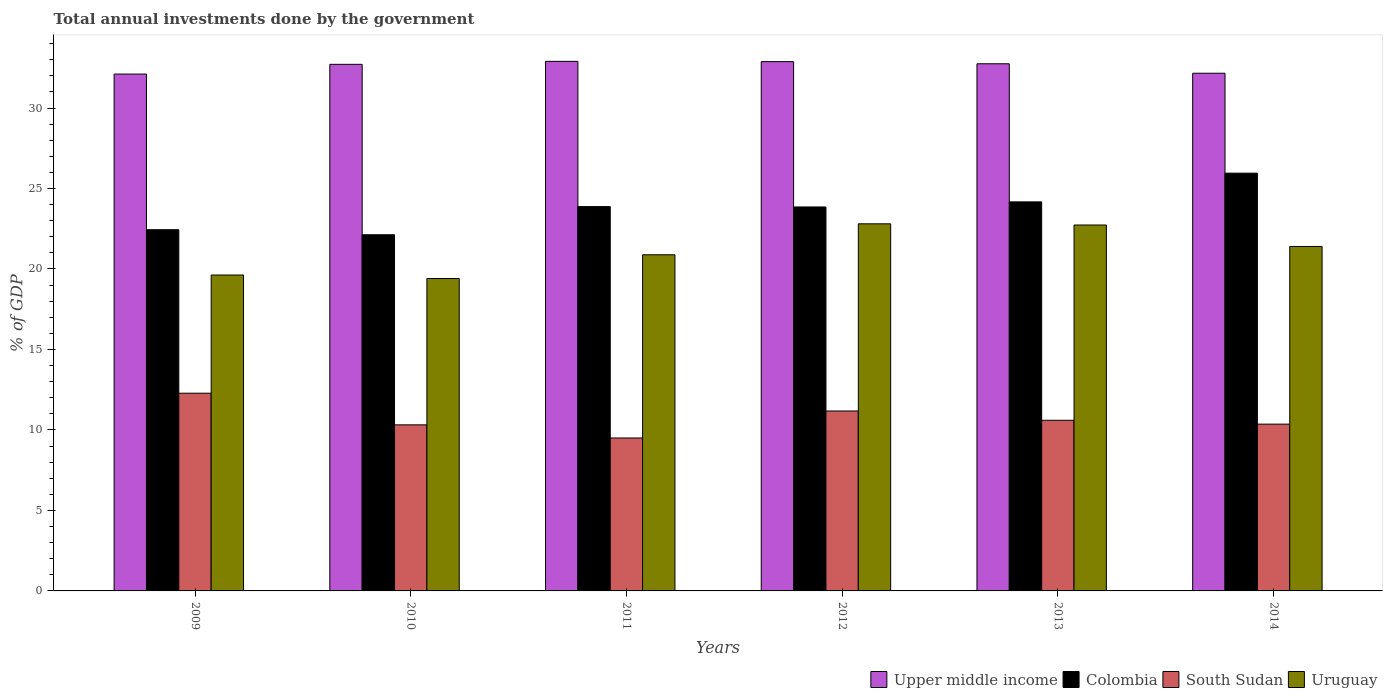How many different coloured bars are there?
Give a very brief answer. 4. How many groups of bars are there?
Provide a short and direct response. 6. How many bars are there on the 5th tick from the right?
Keep it short and to the point. 4. In how many cases, is the number of bars for a given year not equal to the number of legend labels?
Keep it short and to the point. 0. What is the total annual investments done by the government in Upper middle income in 2011?
Give a very brief answer. 32.9. Across all years, what is the maximum total annual investments done by the government in Upper middle income?
Your answer should be very brief. 32.9. Across all years, what is the minimum total annual investments done by the government in Upper middle income?
Offer a terse response. 32.11. In which year was the total annual investments done by the government in Colombia maximum?
Ensure brevity in your answer.  2014. What is the total total annual investments done by the government in Colombia in the graph?
Provide a succinct answer. 142.42. What is the difference between the total annual investments done by the government in Colombia in 2009 and that in 2010?
Ensure brevity in your answer.  0.31. What is the difference between the total annual investments done by the government in South Sudan in 2009 and the total annual investments done by the government in Upper middle income in 2013?
Offer a terse response. -20.47. What is the average total annual investments done by the government in Colombia per year?
Make the answer very short. 23.74. In the year 2012, what is the difference between the total annual investments done by the government in South Sudan and total annual investments done by the government in Uruguay?
Offer a very short reply. -11.63. In how many years, is the total annual investments done by the government in Colombia greater than 24 %?
Provide a succinct answer. 2. What is the ratio of the total annual investments done by the government in South Sudan in 2010 to that in 2011?
Keep it short and to the point. 1.09. Is the total annual investments done by the government in Upper middle income in 2009 less than that in 2012?
Your answer should be very brief. Yes. Is the difference between the total annual investments done by the government in South Sudan in 2010 and 2014 greater than the difference between the total annual investments done by the government in Uruguay in 2010 and 2014?
Give a very brief answer. Yes. What is the difference between the highest and the second highest total annual investments done by the government in Upper middle income?
Your response must be concise. 0.02. What is the difference between the highest and the lowest total annual investments done by the government in Uruguay?
Make the answer very short. 3.4. In how many years, is the total annual investments done by the government in South Sudan greater than the average total annual investments done by the government in South Sudan taken over all years?
Your answer should be compact. 2. Is the sum of the total annual investments done by the government in South Sudan in 2012 and 2014 greater than the maximum total annual investments done by the government in Upper middle income across all years?
Provide a short and direct response. No. Is it the case that in every year, the sum of the total annual investments done by the government in Colombia and total annual investments done by the government in Upper middle income is greater than the sum of total annual investments done by the government in South Sudan and total annual investments done by the government in Uruguay?
Your response must be concise. Yes. What does the 4th bar from the left in 2014 represents?
Provide a succinct answer. Uruguay. What does the 1st bar from the right in 2009 represents?
Provide a succinct answer. Uruguay. What is the difference between two consecutive major ticks on the Y-axis?
Provide a short and direct response. 5. Are the values on the major ticks of Y-axis written in scientific E-notation?
Your answer should be compact. No. Does the graph contain any zero values?
Your answer should be compact. No. Does the graph contain grids?
Your response must be concise. No. How are the legend labels stacked?
Keep it short and to the point. Horizontal. What is the title of the graph?
Offer a very short reply. Total annual investments done by the government. Does "Cote d'Ivoire" appear as one of the legend labels in the graph?
Ensure brevity in your answer.  No. What is the label or title of the Y-axis?
Your answer should be compact. % of GDP. What is the % of GDP of Upper middle income in 2009?
Your response must be concise. 32.11. What is the % of GDP in Colombia in 2009?
Your answer should be compact. 22.44. What is the % of GDP in South Sudan in 2009?
Keep it short and to the point. 12.28. What is the % of GDP of Uruguay in 2009?
Provide a short and direct response. 19.62. What is the % of GDP in Upper middle income in 2010?
Your response must be concise. 32.71. What is the % of GDP of Colombia in 2010?
Your response must be concise. 22.13. What is the % of GDP in South Sudan in 2010?
Provide a short and direct response. 10.32. What is the % of GDP of Uruguay in 2010?
Ensure brevity in your answer.  19.41. What is the % of GDP of Upper middle income in 2011?
Keep it short and to the point. 32.9. What is the % of GDP in Colombia in 2011?
Make the answer very short. 23.88. What is the % of GDP in South Sudan in 2011?
Your response must be concise. 9.5. What is the % of GDP of Uruguay in 2011?
Your response must be concise. 20.88. What is the % of GDP of Upper middle income in 2012?
Keep it short and to the point. 32.88. What is the % of GDP in Colombia in 2012?
Ensure brevity in your answer.  23.85. What is the % of GDP in South Sudan in 2012?
Keep it short and to the point. 11.18. What is the % of GDP of Uruguay in 2012?
Make the answer very short. 22.81. What is the % of GDP in Upper middle income in 2013?
Offer a terse response. 32.75. What is the % of GDP in Colombia in 2013?
Ensure brevity in your answer.  24.17. What is the % of GDP in South Sudan in 2013?
Offer a very short reply. 10.6. What is the % of GDP of Uruguay in 2013?
Keep it short and to the point. 22.73. What is the % of GDP of Upper middle income in 2014?
Keep it short and to the point. 32.16. What is the % of GDP of Colombia in 2014?
Your answer should be very brief. 25.95. What is the % of GDP in South Sudan in 2014?
Your answer should be compact. 10.36. What is the % of GDP of Uruguay in 2014?
Give a very brief answer. 21.4. Across all years, what is the maximum % of GDP of Upper middle income?
Offer a terse response. 32.9. Across all years, what is the maximum % of GDP of Colombia?
Offer a terse response. 25.95. Across all years, what is the maximum % of GDP in South Sudan?
Keep it short and to the point. 12.28. Across all years, what is the maximum % of GDP of Uruguay?
Your response must be concise. 22.81. Across all years, what is the minimum % of GDP in Upper middle income?
Your response must be concise. 32.11. Across all years, what is the minimum % of GDP of Colombia?
Your answer should be compact. 22.13. Across all years, what is the minimum % of GDP of South Sudan?
Keep it short and to the point. 9.5. Across all years, what is the minimum % of GDP of Uruguay?
Offer a very short reply. 19.41. What is the total % of GDP in Upper middle income in the graph?
Your answer should be very brief. 195.51. What is the total % of GDP in Colombia in the graph?
Your answer should be very brief. 142.42. What is the total % of GDP of South Sudan in the graph?
Offer a very short reply. 64.24. What is the total % of GDP of Uruguay in the graph?
Ensure brevity in your answer.  126.85. What is the difference between the % of GDP of Upper middle income in 2009 and that in 2010?
Your response must be concise. -0.6. What is the difference between the % of GDP in Colombia in 2009 and that in 2010?
Provide a short and direct response. 0.31. What is the difference between the % of GDP of South Sudan in 2009 and that in 2010?
Keep it short and to the point. 1.97. What is the difference between the % of GDP in Uruguay in 2009 and that in 2010?
Your response must be concise. 0.22. What is the difference between the % of GDP of Upper middle income in 2009 and that in 2011?
Provide a succinct answer. -0.79. What is the difference between the % of GDP in Colombia in 2009 and that in 2011?
Give a very brief answer. -1.44. What is the difference between the % of GDP of South Sudan in 2009 and that in 2011?
Your response must be concise. 2.78. What is the difference between the % of GDP of Uruguay in 2009 and that in 2011?
Your answer should be very brief. -1.26. What is the difference between the % of GDP of Upper middle income in 2009 and that in 2012?
Offer a terse response. -0.77. What is the difference between the % of GDP in Colombia in 2009 and that in 2012?
Your response must be concise. -1.41. What is the difference between the % of GDP in South Sudan in 2009 and that in 2012?
Provide a short and direct response. 1.1. What is the difference between the % of GDP in Uruguay in 2009 and that in 2012?
Provide a succinct answer. -3.18. What is the difference between the % of GDP of Upper middle income in 2009 and that in 2013?
Keep it short and to the point. -0.64. What is the difference between the % of GDP in Colombia in 2009 and that in 2013?
Give a very brief answer. -1.73. What is the difference between the % of GDP in South Sudan in 2009 and that in 2013?
Make the answer very short. 1.68. What is the difference between the % of GDP of Uruguay in 2009 and that in 2013?
Give a very brief answer. -3.11. What is the difference between the % of GDP of Upper middle income in 2009 and that in 2014?
Your answer should be very brief. -0.05. What is the difference between the % of GDP in Colombia in 2009 and that in 2014?
Provide a succinct answer. -3.51. What is the difference between the % of GDP of South Sudan in 2009 and that in 2014?
Provide a short and direct response. 1.92. What is the difference between the % of GDP in Uruguay in 2009 and that in 2014?
Your answer should be compact. -1.77. What is the difference between the % of GDP of Upper middle income in 2010 and that in 2011?
Offer a terse response. -0.19. What is the difference between the % of GDP of Colombia in 2010 and that in 2011?
Your response must be concise. -1.75. What is the difference between the % of GDP of South Sudan in 2010 and that in 2011?
Keep it short and to the point. 0.82. What is the difference between the % of GDP in Uruguay in 2010 and that in 2011?
Give a very brief answer. -1.47. What is the difference between the % of GDP of Upper middle income in 2010 and that in 2012?
Your response must be concise. -0.17. What is the difference between the % of GDP of Colombia in 2010 and that in 2012?
Provide a short and direct response. -1.73. What is the difference between the % of GDP of South Sudan in 2010 and that in 2012?
Give a very brief answer. -0.86. What is the difference between the % of GDP of Uruguay in 2010 and that in 2012?
Offer a terse response. -3.4. What is the difference between the % of GDP of Upper middle income in 2010 and that in 2013?
Your answer should be compact. -0.04. What is the difference between the % of GDP of Colombia in 2010 and that in 2013?
Your answer should be very brief. -2.04. What is the difference between the % of GDP in South Sudan in 2010 and that in 2013?
Ensure brevity in your answer.  -0.28. What is the difference between the % of GDP of Uruguay in 2010 and that in 2013?
Offer a terse response. -3.32. What is the difference between the % of GDP of Upper middle income in 2010 and that in 2014?
Make the answer very short. 0.55. What is the difference between the % of GDP in Colombia in 2010 and that in 2014?
Your answer should be very brief. -3.83. What is the difference between the % of GDP in South Sudan in 2010 and that in 2014?
Provide a succinct answer. -0.04. What is the difference between the % of GDP of Uruguay in 2010 and that in 2014?
Provide a short and direct response. -1.99. What is the difference between the % of GDP in Upper middle income in 2011 and that in 2012?
Make the answer very short. 0.02. What is the difference between the % of GDP in Colombia in 2011 and that in 2012?
Provide a succinct answer. 0.02. What is the difference between the % of GDP in South Sudan in 2011 and that in 2012?
Your answer should be compact. -1.68. What is the difference between the % of GDP in Uruguay in 2011 and that in 2012?
Make the answer very short. -1.92. What is the difference between the % of GDP in Colombia in 2011 and that in 2013?
Ensure brevity in your answer.  -0.29. What is the difference between the % of GDP in South Sudan in 2011 and that in 2013?
Your answer should be compact. -1.1. What is the difference between the % of GDP of Uruguay in 2011 and that in 2013?
Keep it short and to the point. -1.85. What is the difference between the % of GDP of Upper middle income in 2011 and that in 2014?
Offer a very short reply. 0.74. What is the difference between the % of GDP of Colombia in 2011 and that in 2014?
Give a very brief answer. -2.08. What is the difference between the % of GDP of South Sudan in 2011 and that in 2014?
Keep it short and to the point. -0.86. What is the difference between the % of GDP in Uruguay in 2011 and that in 2014?
Give a very brief answer. -0.52. What is the difference between the % of GDP in Upper middle income in 2012 and that in 2013?
Offer a terse response. 0.13. What is the difference between the % of GDP in Colombia in 2012 and that in 2013?
Offer a terse response. -0.32. What is the difference between the % of GDP in South Sudan in 2012 and that in 2013?
Make the answer very short. 0.58. What is the difference between the % of GDP in Uruguay in 2012 and that in 2013?
Provide a succinct answer. 0.07. What is the difference between the % of GDP of Upper middle income in 2012 and that in 2014?
Your response must be concise. 0.72. What is the difference between the % of GDP in Colombia in 2012 and that in 2014?
Give a very brief answer. -2.1. What is the difference between the % of GDP in South Sudan in 2012 and that in 2014?
Your answer should be very brief. 0.82. What is the difference between the % of GDP of Uruguay in 2012 and that in 2014?
Make the answer very short. 1.41. What is the difference between the % of GDP of Upper middle income in 2013 and that in 2014?
Your answer should be very brief. 0.59. What is the difference between the % of GDP in Colombia in 2013 and that in 2014?
Ensure brevity in your answer.  -1.78. What is the difference between the % of GDP in South Sudan in 2013 and that in 2014?
Provide a succinct answer. 0.24. What is the difference between the % of GDP of Uruguay in 2013 and that in 2014?
Give a very brief answer. 1.33. What is the difference between the % of GDP in Upper middle income in 2009 and the % of GDP in Colombia in 2010?
Offer a terse response. 9.98. What is the difference between the % of GDP of Upper middle income in 2009 and the % of GDP of South Sudan in 2010?
Your response must be concise. 21.79. What is the difference between the % of GDP in Upper middle income in 2009 and the % of GDP in Uruguay in 2010?
Provide a succinct answer. 12.7. What is the difference between the % of GDP of Colombia in 2009 and the % of GDP of South Sudan in 2010?
Ensure brevity in your answer.  12.12. What is the difference between the % of GDP of Colombia in 2009 and the % of GDP of Uruguay in 2010?
Your answer should be very brief. 3.03. What is the difference between the % of GDP in South Sudan in 2009 and the % of GDP in Uruguay in 2010?
Your answer should be very brief. -7.13. What is the difference between the % of GDP of Upper middle income in 2009 and the % of GDP of Colombia in 2011?
Keep it short and to the point. 8.23. What is the difference between the % of GDP in Upper middle income in 2009 and the % of GDP in South Sudan in 2011?
Your answer should be compact. 22.61. What is the difference between the % of GDP in Upper middle income in 2009 and the % of GDP in Uruguay in 2011?
Your answer should be compact. 11.23. What is the difference between the % of GDP in Colombia in 2009 and the % of GDP in South Sudan in 2011?
Make the answer very short. 12.94. What is the difference between the % of GDP in Colombia in 2009 and the % of GDP in Uruguay in 2011?
Provide a succinct answer. 1.56. What is the difference between the % of GDP in Upper middle income in 2009 and the % of GDP in Colombia in 2012?
Provide a succinct answer. 8.26. What is the difference between the % of GDP in Upper middle income in 2009 and the % of GDP in South Sudan in 2012?
Offer a very short reply. 20.93. What is the difference between the % of GDP in Upper middle income in 2009 and the % of GDP in Uruguay in 2012?
Give a very brief answer. 9.3. What is the difference between the % of GDP in Colombia in 2009 and the % of GDP in South Sudan in 2012?
Your response must be concise. 11.26. What is the difference between the % of GDP of Colombia in 2009 and the % of GDP of Uruguay in 2012?
Give a very brief answer. -0.37. What is the difference between the % of GDP in South Sudan in 2009 and the % of GDP in Uruguay in 2012?
Offer a terse response. -10.52. What is the difference between the % of GDP of Upper middle income in 2009 and the % of GDP of Colombia in 2013?
Your answer should be compact. 7.94. What is the difference between the % of GDP in Upper middle income in 2009 and the % of GDP in South Sudan in 2013?
Keep it short and to the point. 21.51. What is the difference between the % of GDP in Upper middle income in 2009 and the % of GDP in Uruguay in 2013?
Give a very brief answer. 9.38. What is the difference between the % of GDP in Colombia in 2009 and the % of GDP in South Sudan in 2013?
Offer a terse response. 11.84. What is the difference between the % of GDP of Colombia in 2009 and the % of GDP of Uruguay in 2013?
Provide a short and direct response. -0.29. What is the difference between the % of GDP in South Sudan in 2009 and the % of GDP in Uruguay in 2013?
Provide a short and direct response. -10.45. What is the difference between the % of GDP in Upper middle income in 2009 and the % of GDP in Colombia in 2014?
Your answer should be very brief. 6.16. What is the difference between the % of GDP of Upper middle income in 2009 and the % of GDP of South Sudan in 2014?
Your answer should be very brief. 21.75. What is the difference between the % of GDP of Upper middle income in 2009 and the % of GDP of Uruguay in 2014?
Give a very brief answer. 10.71. What is the difference between the % of GDP of Colombia in 2009 and the % of GDP of South Sudan in 2014?
Ensure brevity in your answer.  12.08. What is the difference between the % of GDP of Colombia in 2009 and the % of GDP of Uruguay in 2014?
Offer a very short reply. 1.04. What is the difference between the % of GDP of South Sudan in 2009 and the % of GDP of Uruguay in 2014?
Give a very brief answer. -9.12. What is the difference between the % of GDP in Upper middle income in 2010 and the % of GDP in Colombia in 2011?
Provide a succinct answer. 8.84. What is the difference between the % of GDP of Upper middle income in 2010 and the % of GDP of South Sudan in 2011?
Offer a very short reply. 23.21. What is the difference between the % of GDP in Upper middle income in 2010 and the % of GDP in Uruguay in 2011?
Give a very brief answer. 11.83. What is the difference between the % of GDP in Colombia in 2010 and the % of GDP in South Sudan in 2011?
Your response must be concise. 12.62. What is the difference between the % of GDP of Colombia in 2010 and the % of GDP of Uruguay in 2011?
Offer a terse response. 1.24. What is the difference between the % of GDP in South Sudan in 2010 and the % of GDP in Uruguay in 2011?
Give a very brief answer. -10.57. What is the difference between the % of GDP in Upper middle income in 2010 and the % of GDP in Colombia in 2012?
Make the answer very short. 8.86. What is the difference between the % of GDP in Upper middle income in 2010 and the % of GDP in South Sudan in 2012?
Make the answer very short. 21.54. What is the difference between the % of GDP of Upper middle income in 2010 and the % of GDP of Uruguay in 2012?
Your answer should be very brief. 9.91. What is the difference between the % of GDP in Colombia in 2010 and the % of GDP in South Sudan in 2012?
Ensure brevity in your answer.  10.95. What is the difference between the % of GDP of Colombia in 2010 and the % of GDP of Uruguay in 2012?
Give a very brief answer. -0.68. What is the difference between the % of GDP in South Sudan in 2010 and the % of GDP in Uruguay in 2012?
Your answer should be compact. -12.49. What is the difference between the % of GDP in Upper middle income in 2010 and the % of GDP in Colombia in 2013?
Give a very brief answer. 8.54. What is the difference between the % of GDP of Upper middle income in 2010 and the % of GDP of South Sudan in 2013?
Your answer should be compact. 22.11. What is the difference between the % of GDP of Upper middle income in 2010 and the % of GDP of Uruguay in 2013?
Provide a short and direct response. 9.98. What is the difference between the % of GDP of Colombia in 2010 and the % of GDP of South Sudan in 2013?
Your answer should be very brief. 11.53. What is the difference between the % of GDP of Colombia in 2010 and the % of GDP of Uruguay in 2013?
Offer a very short reply. -0.61. What is the difference between the % of GDP in South Sudan in 2010 and the % of GDP in Uruguay in 2013?
Ensure brevity in your answer.  -12.41. What is the difference between the % of GDP of Upper middle income in 2010 and the % of GDP of Colombia in 2014?
Provide a succinct answer. 6.76. What is the difference between the % of GDP of Upper middle income in 2010 and the % of GDP of South Sudan in 2014?
Your answer should be compact. 22.35. What is the difference between the % of GDP of Upper middle income in 2010 and the % of GDP of Uruguay in 2014?
Offer a terse response. 11.31. What is the difference between the % of GDP of Colombia in 2010 and the % of GDP of South Sudan in 2014?
Make the answer very short. 11.76. What is the difference between the % of GDP of Colombia in 2010 and the % of GDP of Uruguay in 2014?
Offer a very short reply. 0.73. What is the difference between the % of GDP of South Sudan in 2010 and the % of GDP of Uruguay in 2014?
Give a very brief answer. -11.08. What is the difference between the % of GDP of Upper middle income in 2011 and the % of GDP of Colombia in 2012?
Your answer should be very brief. 9.05. What is the difference between the % of GDP of Upper middle income in 2011 and the % of GDP of South Sudan in 2012?
Give a very brief answer. 21.72. What is the difference between the % of GDP in Upper middle income in 2011 and the % of GDP in Uruguay in 2012?
Provide a short and direct response. 10.09. What is the difference between the % of GDP of Colombia in 2011 and the % of GDP of South Sudan in 2012?
Keep it short and to the point. 12.7. What is the difference between the % of GDP of Colombia in 2011 and the % of GDP of Uruguay in 2012?
Offer a very short reply. 1.07. What is the difference between the % of GDP in South Sudan in 2011 and the % of GDP in Uruguay in 2012?
Your response must be concise. -13.3. What is the difference between the % of GDP in Upper middle income in 2011 and the % of GDP in Colombia in 2013?
Ensure brevity in your answer.  8.73. What is the difference between the % of GDP of Upper middle income in 2011 and the % of GDP of South Sudan in 2013?
Provide a succinct answer. 22.3. What is the difference between the % of GDP of Upper middle income in 2011 and the % of GDP of Uruguay in 2013?
Provide a succinct answer. 10.17. What is the difference between the % of GDP of Colombia in 2011 and the % of GDP of South Sudan in 2013?
Offer a terse response. 13.28. What is the difference between the % of GDP in Colombia in 2011 and the % of GDP in Uruguay in 2013?
Ensure brevity in your answer.  1.14. What is the difference between the % of GDP in South Sudan in 2011 and the % of GDP in Uruguay in 2013?
Provide a short and direct response. -13.23. What is the difference between the % of GDP of Upper middle income in 2011 and the % of GDP of Colombia in 2014?
Provide a short and direct response. 6.95. What is the difference between the % of GDP in Upper middle income in 2011 and the % of GDP in South Sudan in 2014?
Make the answer very short. 22.54. What is the difference between the % of GDP of Colombia in 2011 and the % of GDP of South Sudan in 2014?
Keep it short and to the point. 13.51. What is the difference between the % of GDP of Colombia in 2011 and the % of GDP of Uruguay in 2014?
Provide a short and direct response. 2.48. What is the difference between the % of GDP of South Sudan in 2011 and the % of GDP of Uruguay in 2014?
Provide a short and direct response. -11.9. What is the difference between the % of GDP in Upper middle income in 2012 and the % of GDP in Colombia in 2013?
Your response must be concise. 8.71. What is the difference between the % of GDP in Upper middle income in 2012 and the % of GDP in South Sudan in 2013?
Provide a succinct answer. 22.28. What is the difference between the % of GDP of Upper middle income in 2012 and the % of GDP of Uruguay in 2013?
Give a very brief answer. 10.15. What is the difference between the % of GDP in Colombia in 2012 and the % of GDP in South Sudan in 2013?
Provide a short and direct response. 13.25. What is the difference between the % of GDP in Colombia in 2012 and the % of GDP in Uruguay in 2013?
Your answer should be compact. 1.12. What is the difference between the % of GDP of South Sudan in 2012 and the % of GDP of Uruguay in 2013?
Offer a very short reply. -11.55. What is the difference between the % of GDP in Upper middle income in 2012 and the % of GDP in Colombia in 2014?
Offer a terse response. 6.93. What is the difference between the % of GDP in Upper middle income in 2012 and the % of GDP in South Sudan in 2014?
Your answer should be very brief. 22.52. What is the difference between the % of GDP in Upper middle income in 2012 and the % of GDP in Uruguay in 2014?
Your response must be concise. 11.48. What is the difference between the % of GDP in Colombia in 2012 and the % of GDP in South Sudan in 2014?
Provide a short and direct response. 13.49. What is the difference between the % of GDP of Colombia in 2012 and the % of GDP of Uruguay in 2014?
Provide a succinct answer. 2.45. What is the difference between the % of GDP of South Sudan in 2012 and the % of GDP of Uruguay in 2014?
Provide a short and direct response. -10.22. What is the difference between the % of GDP of Upper middle income in 2013 and the % of GDP of Colombia in 2014?
Your answer should be very brief. 6.8. What is the difference between the % of GDP of Upper middle income in 2013 and the % of GDP of South Sudan in 2014?
Your answer should be very brief. 22.39. What is the difference between the % of GDP of Upper middle income in 2013 and the % of GDP of Uruguay in 2014?
Give a very brief answer. 11.35. What is the difference between the % of GDP in Colombia in 2013 and the % of GDP in South Sudan in 2014?
Ensure brevity in your answer.  13.81. What is the difference between the % of GDP of Colombia in 2013 and the % of GDP of Uruguay in 2014?
Offer a terse response. 2.77. What is the difference between the % of GDP of South Sudan in 2013 and the % of GDP of Uruguay in 2014?
Provide a succinct answer. -10.8. What is the average % of GDP in Upper middle income per year?
Offer a terse response. 32.58. What is the average % of GDP of Colombia per year?
Make the answer very short. 23.74. What is the average % of GDP in South Sudan per year?
Your answer should be very brief. 10.71. What is the average % of GDP of Uruguay per year?
Give a very brief answer. 21.14. In the year 2009, what is the difference between the % of GDP of Upper middle income and % of GDP of Colombia?
Provide a short and direct response. 9.67. In the year 2009, what is the difference between the % of GDP of Upper middle income and % of GDP of South Sudan?
Offer a very short reply. 19.83. In the year 2009, what is the difference between the % of GDP of Upper middle income and % of GDP of Uruguay?
Your answer should be very brief. 12.48. In the year 2009, what is the difference between the % of GDP of Colombia and % of GDP of South Sudan?
Your answer should be compact. 10.16. In the year 2009, what is the difference between the % of GDP of Colombia and % of GDP of Uruguay?
Offer a terse response. 2.82. In the year 2009, what is the difference between the % of GDP in South Sudan and % of GDP in Uruguay?
Your response must be concise. -7.34. In the year 2010, what is the difference between the % of GDP in Upper middle income and % of GDP in Colombia?
Provide a succinct answer. 10.59. In the year 2010, what is the difference between the % of GDP of Upper middle income and % of GDP of South Sudan?
Your answer should be compact. 22.4. In the year 2010, what is the difference between the % of GDP in Upper middle income and % of GDP in Uruguay?
Give a very brief answer. 13.31. In the year 2010, what is the difference between the % of GDP in Colombia and % of GDP in South Sudan?
Offer a terse response. 11.81. In the year 2010, what is the difference between the % of GDP of Colombia and % of GDP of Uruguay?
Offer a very short reply. 2.72. In the year 2010, what is the difference between the % of GDP of South Sudan and % of GDP of Uruguay?
Offer a terse response. -9.09. In the year 2011, what is the difference between the % of GDP in Upper middle income and % of GDP in Colombia?
Provide a succinct answer. 9.02. In the year 2011, what is the difference between the % of GDP in Upper middle income and % of GDP in South Sudan?
Offer a very short reply. 23.4. In the year 2011, what is the difference between the % of GDP of Upper middle income and % of GDP of Uruguay?
Offer a terse response. 12.02. In the year 2011, what is the difference between the % of GDP in Colombia and % of GDP in South Sudan?
Make the answer very short. 14.37. In the year 2011, what is the difference between the % of GDP in Colombia and % of GDP in Uruguay?
Your answer should be compact. 2.99. In the year 2011, what is the difference between the % of GDP of South Sudan and % of GDP of Uruguay?
Provide a succinct answer. -11.38. In the year 2012, what is the difference between the % of GDP of Upper middle income and % of GDP of Colombia?
Offer a terse response. 9.03. In the year 2012, what is the difference between the % of GDP in Upper middle income and % of GDP in South Sudan?
Your answer should be very brief. 21.7. In the year 2012, what is the difference between the % of GDP in Upper middle income and % of GDP in Uruguay?
Provide a short and direct response. 10.08. In the year 2012, what is the difference between the % of GDP of Colombia and % of GDP of South Sudan?
Provide a short and direct response. 12.67. In the year 2012, what is the difference between the % of GDP of Colombia and % of GDP of Uruguay?
Your answer should be compact. 1.05. In the year 2012, what is the difference between the % of GDP of South Sudan and % of GDP of Uruguay?
Your response must be concise. -11.63. In the year 2013, what is the difference between the % of GDP of Upper middle income and % of GDP of Colombia?
Provide a short and direct response. 8.58. In the year 2013, what is the difference between the % of GDP of Upper middle income and % of GDP of South Sudan?
Give a very brief answer. 22.15. In the year 2013, what is the difference between the % of GDP in Upper middle income and % of GDP in Uruguay?
Make the answer very short. 10.02. In the year 2013, what is the difference between the % of GDP in Colombia and % of GDP in South Sudan?
Your response must be concise. 13.57. In the year 2013, what is the difference between the % of GDP of Colombia and % of GDP of Uruguay?
Offer a terse response. 1.44. In the year 2013, what is the difference between the % of GDP in South Sudan and % of GDP in Uruguay?
Ensure brevity in your answer.  -12.13. In the year 2014, what is the difference between the % of GDP in Upper middle income and % of GDP in Colombia?
Provide a short and direct response. 6.21. In the year 2014, what is the difference between the % of GDP of Upper middle income and % of GDP of South Sudan?
Offer a very short reply. 21.8. In the year 2014, what is the difference between the % of GDP of Upper middle income and % of GDP of Uruguay?
Your answer should be very brief. 10.76. In the year 2014, what is the difference between the % of GDP of Colombia and % of GDP of South Sudan?
Ensure brevity in your answer.  15.59. In the year 2014, what is the difference between the % of GDP in Colombia and % of GDP in Uruguay?
Keep it short and to the point. 4.55. In the year 2014, what is the difference between the % of GDP of South Sudan and % of GDP of Uruguay?
Ensure brevity in your answer.  -11.04. What is the ratio of the % of GDP in Upper middle income in 2009 to that in 2010?
Ensure brevity in your answer.  0.98. What is the ratio of the % of GDP of Colombia in 2009 to that in 2010?
Provide a short and direct response. 1.01. What is the ratio of the % of GDP in South Sudan in 2009 to that in 2010?
Your answer should be very brief. 1.19. What is the ratio of the % of GDP of Uruguay in 2009 to that in 2010?
Your answer should be very brief. 1.01. What is the ratio of the % of GDP in Colombia in 2009 to that in 2011?
Offer a terse response. 0.94. What is the ratio of the % of GDP in South Sudan in 2009 to that in 2011?
Make the answer very short. 1.29. What is the ratio of the % of GDP of Uruguay in 2009 to that in 2011?
Provide a short and direct response. 0.94. What is the ratio of the % of GDP of Upper middle income in 2009 to that in 2012?
Your answer should be very brief. 0.98. What is the ratio of the % of GDP of Colombia in 2009 to that in 2012?
Provide a short and direct response. 0.94. What is the ratio of the % of GDP of South Sudan in 2009 to that in 2012?
Provide a succinct answer. 1.1. What is the ratio of the % of GDP in Uruguay in 2009 to that in 2012?
Offer a terse response. 0.86. What is the ratio of the % of GDP of Upper middle income in 2009 to that in 2013?
Your answer should be compact. 0.98. What is the ratio of the % of GDP of Colombia in 2009 to that in 2013?
Ensure brevity in your answer.  0.93. What is the ratio of the % of GDP in South Sudan in 2009 to that in 2013?
Your response must be concise. 1.16. What is the ratio of the % of GDP in Uruguay in 2009 to that in 2013?
Offer a very short reply. 0.86. What is the ratio of the % of GDP of Upper middle income in 2009 to that in 2014?
Offer a terse response. 1. What is the ratio of the % of GDP in Colombia in 2009 to that in 2014?
Make the answer very short. 0.86. What is the ratio of the % of GDP of South Sudan in 2009 to that in 2014?
Provide a short and direct response. 1.19. What is the ratio of the % of GDP in Uruguay in 2009 to that in 2014?
Your answer should be compact. 0.92. What is the ratio of the % of GDP in Upper middle income in 2010 to that in 2011?
Provide a short and direct response. 0.99. What is the ratio of the % of GDP in Colombia in 2010 to that in 2011?
Your answer should be very brief. 0.93. What is the ratio of the % of GDP of South Sudan in 2010 to that in 2011?
Keep it short and to the point. 1.09. What is the ratio of the % of GDP of Uruguay in 2010 to that in 2011?
Provide a succinct answer. 0.93. What is the ratio of the % of GDP of Upper middle income in 2010 to that in 2012?
Offer a terse response. 0.99. What is the ratio of the % of GDP of Colombia in 2010 to that in 2012?
Ensure brevity in your answer.  0.93. What is the ratio of the % of GDP of South Sudan in 2010 to that in 2012?
Your response must be concise. 0.92. What is the ratio of the % of GDP in Uruguay in 2010 to that in 2012?
Provide a succinct answer. 0.85. What is the ratio of the % of GDP of Upper middle income in 2010 to that in 2013?
Offer a very short reply. 1. What is the ratio of the % of GDP in Colombia in 2010 to that in 2013?
Offer a terse response. 0.92. What is the ratio of the % of GDP of South Sudan in 2010 to that in 2013?
Offer a very short reply. 0.97. What is the ratio of the % of GDP of Uruguay in 2010 to that in 2013?
Offer a very short reply. 0.85. What is the ratio of the % of GDP of Upper middle income in 2010 to that in 2014?
Provide a short and direct response. 1.02. What is the ratio of the % of GDP in Colombia in 2010 to that in 2014?
Your answer should be compact. 0.85. What is the ratio of the % of GDP of Uruguay in 2010 to that in 2014?
Ensure brevity in your answer.  0.91. What is the ratio of the % of GDP in Upper middle income in 2011 to that in 2012?
Ensure brevity in your answer.  1. What is the ratio of the % of GDP of South Sudan in 2011 to that in 2012?
Provide a short and direct response. 0.85. What is the ratio of the % of GDP of Uruguay in 2011 to that in 2012?
Provide a short and direct response. 0.92. What is the ratio of the % of GDP of Colombia in 2011 to that in 2013?
Provide a short and direct response. 0.99. What is the ratio of the % of GDP in South Sudan in 2011 to that in 2013?
Provide a short and direct response. 0.9. What is the ratio of the % of GDP in Uruguay in 2011 to that in 2013?
Provide a short and direct response. 0.92. What is the ratio of the % of GDP of Upper middle income in 2011 to that in 2014?
Offer a very short reply. 1.02. What is the ratio of the % of GDP of South Sudan in 2011 to that in 2014?
Ensure brevity in your answer.  0.92. What is the ratio of the % of GDP of Uruguay in 2011 to that in 2014?
Provide a short and direct response. 0.98. What is the ratio of the % of GDP of Upper middle income in 2012 to that in 2013?
Make the answer very short. 1. What is the ratio of the % of GDP in Colombia in 2012 to that in 2013?
Provide a short and direct response. 0.99. What is the ratio of the % of GDP of South Sudan in 2012 to that in 2013?
Offer a terse response. 1.05. What is the ratio of the % of GDP in Upper middle income in 2012 to that in 2014?
Keep it short and to the point. 1.02. What is the ratio of the % of GDP of Colombia in 2012 to that in 2014?
Offer a very short reply. 0.92. What is the ratio of the % of GDP in South Sudan in 2012 to that in 2014?
Your answer should be very brief. 1.08. What is the ratio of the % of GDP of Uruguay in 2012 to that in 2014?
Ensure brevity in your answer.  1.07. What is the ratio of the % of GDP of Upper middle income in 2013 to that in 2014?
Your response must be concise. 1.02. What is the ratio of the % of GDP of Colombia in 2013 to that in 2014?
Your answer should be very brief. 0.93. What is the ratio of the % of GDP of South Sudan in 2013 to that in 2014?
Offer a very short reply. 1.02. What is the ratio of the % of GDP of Uruguay in 2013 to that in 2014?
Your answer should be very brief. 1.06. What is the difference between the highest and the second highest % of GDP in Upper middle income?
Make the answer very short. 0.02. What is the difference between the highest and the second highest % of GDP in Colombia?
Make the answer very short. 1.78. What is the difference between the highest and the second highest % of GDP in South Sudan?
Offer a terse response. 1.1. What is the difference between the highest and the second highest % of GDP of Uruguay?
Your answer should be very brief. 0.07. What is the difference between the highest and the lowest % of GDP in Upper middle income?
Provide a succinct answer. 0.79. What is the difference between the highest and the lowest % of GDP of Colombia?
Your answer should be very brief. 3.83. What is the difference between the highest and the lowest % of GDP of South Sudan?
Provide a short and direct response. 2.78. What is the difference between the highest and the lowest % of GDP in Uruguay?
Your response must be concise. 3.4. 